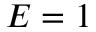Convert formula to latex. <formula><loc_0><loc_0><loc_500><loc_500>E = 1</formula> 